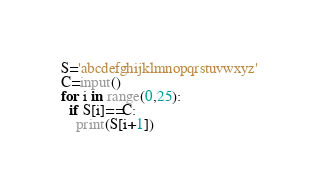Convert code to text. <code><loc_0><loc_0><loc_500><loc_500><_Python_>S='abcdefghijklmnopqrstuvwxyz'
C=input()
for i in range(0,25):
  if S[i]==C:
    print(S[i+1])</code> 